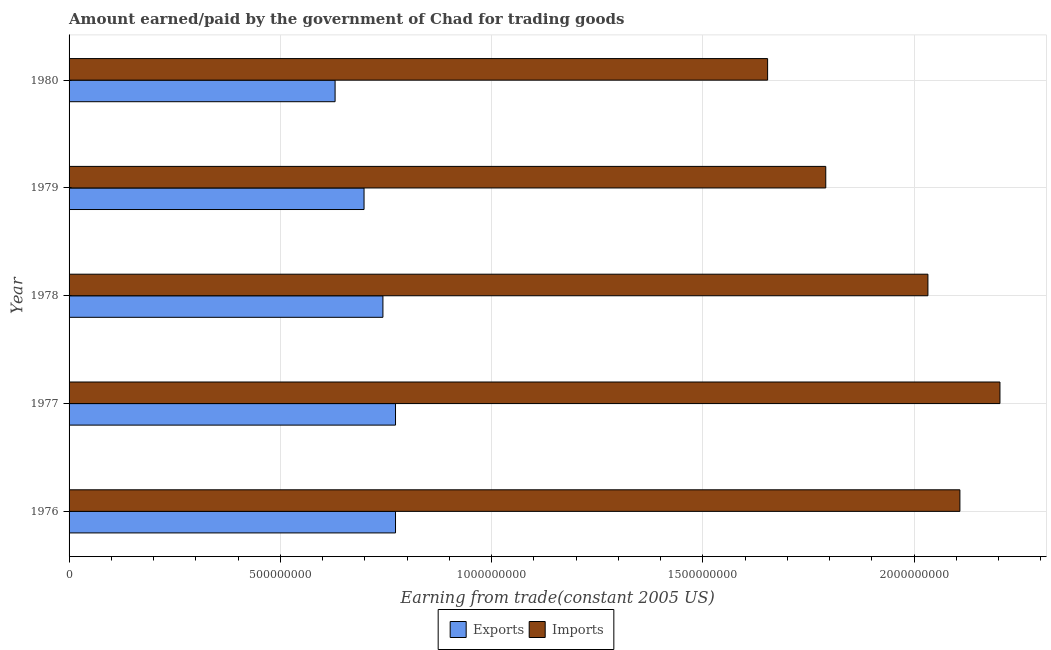How many groups of bars are there?
Make the answer very short. 5. What is the label of the 3rd group of bars from the top?
Make the answer very short. 1978. In how many cases, is the number of bars for a given year not equal to the number of legend labels?
Offer a very short reply. 0. What is the amount paid for imports in 1977?
Provide a succinct answer. 2.20e+09. Across all years, what is the maximum amount earned from exports?
Your answer should be very brief. 7.73e+08. Across all years, what is the minimum amount paid for imports?
Make the answer very short. 1.65e+09. In which year was the amount paid for imports minimum?
Keep it short and to the point. 1980. What is the total amount paid for imports in the graph?
Give a very brief answer. 9.79e+09. What is the difference between the amount earned from exports in 1976 and that in 1979?
Your answer should be very brief. 7.45e+07. What is the difference between the amount earned from exports in 1979 and the amount paid for imports in 1976?
Ensure brevity in your answer.  -1.41e+09. What is the average amount earned from exports per year?
Ensure brevity in your answer.  7.23e+08. In the year 1977, what is the difference between the amount earned from exports and amount paid for imports?
Keep it short and to the point. -1.43e+09. Is the amount earned from exports in 1978 less than that in 1979?
Offer a very short reply. No. What is the difference between the highest and the second highest amount paid for imports?
Your response must be concise. 9.48e+07. What is the difference between the highest and the lowest amount earned from exports?
Keep it short and to the point. 1.43e+08. In how many years, is the amount paid for imports greater than the average amount paid for imports taken over all years?
Offer a terse response. 3. What does the 2nd bar from the top in 1979 represents?
Your answer should be compact. Exports. What does the 1st bar from the bottom in 1976 represents?
Provide a short and direct response. Exports. How many bars are there?
Ensure brevity in your answer.  10. Are all the bars in the graph horizontal?
Give a very brief answer. Yes. How many years are there in the graph?
Ensure brevity in your answer.  5. What is the difference between two consecutive major ticks on the X-axis?
Make the answer very short. 5.00e+08. Does the graph contain grids?
Ensure brevity in your answer.  Yes. What is the title of the graph?
Offer a terse response. Amount earned/paid by the government of Chad for trading goods. Does "Under-five" appear as one of the legend labels in the graph?
Your answer should be very brief. No. What is the label or title of the X-axis?
Give a very brief answer. Earning from trade(constant 2005 US). What is the Earning from trade(constant 2005 US) of Exports in 1976?
Your answer should be very brief. 7.73e+08. What is the Earning from trade(constant 2005 US) of Imports in 1976?
Keep it short and to the point. 2.11e+09. What is the Earning from trade(constant 2005 US) in Exports in 1977?
Your answer should be very brief. 7.73e+08. What is the Earning from trade(constant 2005 US) in Imports in 1977?
Your answer should be compact. 2.20e+09. What is the Earning from trade(constant 2005 US) in Exports in 1978?
Your answer should be very brief. 7.43e+08. What is the Earning from trade(constant 2005 US) of Imports in 1978?
Your answer should be compact. 2.03e+09. What is the Earning from trade(constant 2005 US) of Exports in 1979?
Give a very brief answer. 6.98e+08. What is the Earning from trade(constant 2005 US) of Imports in 1979?
Your response must be concise. 1.79e+09. What is the Earning from trade(constant 2005 US) of Exports in 1980?
Your response must be concise. 6.30e+08. What is the Earning from trade(constant 2005 US) in Imports in 1980?
Offer a very short reply. 1.65e+09. Across all years, what is the maximum Earning from trade(constant 2005 US) in Exports?
Keep it short and to the point. 7.73e+08. Across all years, what is the maximum Earning from trade(constant 2005 US) of Imports?
Your answer should be very brief. 2.20e+09. Across all years, what is the minimum Earning from trade(constant 2005 US) in Exports?
Give a very brief answer. 6.30e+08. Across all years, what is the minimum Earning from trade(constant 2005 US) of Imports?
Keep it short and to the point. 1.65e+09. What is the total Earning from trade(constant 2005 US) of Exports in the graph?
Offer a terse response. 3.62e+09. What is the total Earning from trade(constant 2005 US) of Imports in the graph?
Provide a short and direct response. 9.79e+09. What is the difference between the Earning from trade(constant 2005 US) of Exports in 1976 and that in 1977?
Your answer should be very brief. -1.77e+04. What is the difference between the Earning from trade(constant 2005 US) of Imports in 1976 and that in 1977?
Your response must be concise. -9.48e+07. What is the difference between the Earning from trade(constant 2005 US) in Exports in 1976 and that in 1978?
Provide a succinct answer. 2.98e+07. What is the difference between the Earning from trade(constant 2005 US) in Imports in 1976 and that in 1978?
Keep it short and to the point. 7.57e+07. What is the difference between the Earning from trade(constant 2005 US) of Exports in 1976 and that in 1979?
Keep it short and to the point. 7.45e+07. What is the difference between the Earning from trade(constant 2005 US) of Imports in 1976 and that in 1979?
Ensure brevity in your answer.  3.17e+08. What is the difference between the Earning from trade(constant 2005 US) in Exports in 1976 and that in 1980?
Your answer should be very brief. 1.43e+08. What is the difference between the Earning from trade(constant 2005 US) in Imports in 1976 and that in 1980?
Ensure brevity in your answer.  4.55e+08. What is the difference between the Earning from trade(constant 2005 US) of Exports in 1977 and that in 1978?
Ensure brevity in your answer.  2.98e+07. What is the difference between the Earning from trade(constant 2005 US) in Imports in 1977 and that in 1978?
Offer a very short reply. 1.70e+08. What is the difference between the Earning from trade(constant 2005 US) in Exports in 1977 and that in 1979?
Keep it short and to the point. 7.45e+07. What is the difference between the Earning from trade(constant 2005 US) of Imports in 1977 and that in 1979?
Your answer should be very brief. 4.12e+08. What is the difference between the Earning from trade(constant 2005 US) in Exports in 1977 and that in 1980?
Give a very brief answer. 1.43e+08. What is the difference between the Earning from trade(constant 2005 US) of Imports in 1977 and that in 1980?
Provide a succinct answer. 5.50e+08. What is the difference between the Earning from trade(constant 2005 US) of Exports in 1978 and that in 1979?
Provide a succinct answer. 4.47e+07. What is the difference between the Earning from trade(constant 2005 US) of Imports in 1978 and that in 1979?
Give a very brief answer. 2.42e+08. What is the difference between the Earning from trade(constant 2005 US) of Exports in 1978 and that in 1980?
Your answer should be compact. 1.13e+08. What is the difference between the Earning from trade(constant 2005 US) in Imports in 1978 and that in 1980?
Keep it short and to the point. 3.79e+08. What is the difference between the Earning from trade(constant 2005 US) of Exports in 1979 and that in 1980?
Keep it short and to the point. 6.85e+07. What is the difference between the Earning from trade(constant 2005 US) in Imports in 1979 and that in 1980?
Your response must be concise. 1.38e+08. What is the difference between the Earning from trade(constant 2005 US) of Exports in 1976 and the Earning from trade(constant 2005 US) of Imports in 1977?
Your answer should be very brief. -1.43e+09. What is the difference between the Earning from trade(constant 2005 US) of Exports in 1976 and the Earning from trade(constant 2005 US) of Imports in 1978?
Offer a very short reply. -1.26e+09. What is the difference between the Earning from trade(constant 2005 US) of Exports in 1976 and the Earning from trade(constant 2005 US) of Imports in 1979?
Keep it short and to the point. -1.02e+09. What is the difference between the Earning from trade(constant 2005 US) of Exports in 1976 and the Earning from trade(constant 2005 US) of Imports in 1980?
Your answer should be very brief. -8.81e+08. What is the difference between the Earning from trade(constant 2005 US) in Exports in 1977 and the Earning from trade(constant 2005 US) in Imports in 1978?
Make the answer very short. -1.26e+09. What is the difference between the Earning from trade(constant 2005 US) in Exports in 1977 and the Earning from trade(constant 2005 US) in Imports in 1979?
Your answer should be very brief. -1.02e+09. What is the difference between the Earning from trade(constant 2005 US) of Exports in 1977 and the Earning from trade(constant 2005 US) of Imports in 1980?
Provide a succinct answer. -8.81e+08. What is the difference between the Earning from trade(constant 2005 US) in Exports in 1978 and the Earning from trade(constant 2005 US) in Imports in 1979?
Offer a very short reply. -1.05e+09. What is the difference between the Earning from trade(constant 2005 US) of Exports in 1978 and the Earning from trade(constant 2005 US) of Imports in 1980?
Provide a short and direct response. -9.10e+08. What is the difference between the Earning from trade(constant 2005 US) in Exports in 1979 and the Earning from trade(constant 2005 US) in Imports in 1980?
Provide a short and direct response. -9.55e+08. What is the average Earning from trade(constant 2005 US) in Exports per year?
Ensure brevity in your answer.  7.23e+08. What is the average Earning from trade(constant 2005 US) in Imports per year?
Your answer should be compact. 1.96e+09. In the year 1976, what is the difference between the Earning from trade(constant 2005 US) in Exports and Earning from trade(constant 2005 US) in Imports?
Keep it short and to the point. -1.34e+09. In the year 1977, what is the difference between the Earning from trade(constant 2005 US) of Exports and Earning from trade(constant 2005 US) of Imports?
Your response must be concise. -1.43e+09. In the year 1978, what is the difference between the Earning from trade(constant 2005 US) of Exports and Earning from trade(constant 2005 US) of Imports?
Make the answer very short. -1.29e+09. In the year 1979, what is the difference between the Earning from trade(constant 2005 US) in Exports and Earning from trade(constant 2005 US) in Imports?
Your answer should be very brief. -1.09e+09. In the year 1980, what is the difference between the Earning from trade(constant 2005 US) in Exports and Earning from trade(constant 2005 US) in Imports?
Your answer should be very brief. -1.02e+09. What is the ratio of the Earning from trade(constant 2005 US) of Exports in 1976 to that in 1977?
Provide a succinct answer. 1. What is the ratio of the Earning from trade(constant 2005 US) of Imports in 1976 to that in 1977?
Provide a succinct answer. 0.96. What is the ratio of the Earning from trade(constant 2005 US) in Exports in 1976 to that in 1978?
Make the answer very short. 1.04. What is the ratio of the Earning from trade(constant 2005 US) of Imports in 1976 to that in 1978?
Ensure brevity in your answer.  1.04. What is the ratio of the Earning from trade(constant 2005 US) in Exports in 1976 to that in 1979?
Give a very brief answer. 1.11. What is the ratio of the Earning from trade(constant 2005 US) of Imports in 1976 to that in 1979?
Provide a succinct answer. 1.18. What is the ratio of the Earning from trade(constant 2005 US) in Exports in 1976 to that in 1980?
Make the answer very short. 1.23. What is the ratio of the Earning from trade(constant 2005 US) in Imports in 1976 to that in 1980?
Keep it short and to the point. 1.28. What is the ratio of the Earning from trade(constant 2005 US) of Exports in 1977 to that in 1978?
Provide a succinct answer. 1.04. What is the ratio of the Earning from trade(constant 2005 US) of Imports in 1977 to that in 1978?
Provide a short and direct response. 1.08. What is the ratio of the Earning from trade(constant 2005 US) in Exports in 1977 to that in 1979?
Provide a short and direct response. 1.11. What is the ratio of the Earning from trade(constant 2005 US) of Imports in 1977 to that in 1979?
Ensure brevity in your answer.  1.23. What is the ratio of the Earning from trade(constant 2005 US) in Exports in 1977 to that in 1980?
Offer a terse response. 1.23. What is the ratio of the Earning from trade(constant 2005 US) in Imports in 1977 to that in 1980?
Offer a very short reply. 1.33. What is the ratio of the Earning from trade(constant 2005 US) in Exports in 1978 to that in 1979?
Your answer should be compact. 1.06. What is the ratio of the Earning from trade(constant 2005 US) of Imports in 1978 to that in 1979?
Give a very brief answer. 1.14. What is the ratio of the Earning from trade(constant 2005 US) of Exports in 1978 to that in 1980?
Offer a very short reply. 1.18. What is the ratio of the Earning from trade(constant 2005 US) in Imports in 1978 to that in 1980?
Keep it short and to the point. 1.23. What is the ratio of the Earning from trade(constant 2005 US) of Exports in 1979 to that in 1980?
Keep it short and to the point. 1.11. What is the difference between the highest and the second highest Earning from trade(constant 2005 US) in Exports?
Provide a short and direct response. 1.77e+04. What is the difference between the highest and the second highest Earning from trade(constant 2005 US) in Imports?
Offer a very short reply. 9.48e+07. What is the difference between the highest and the lowest Earning from trade(constant 2005 US) of Exports?
Your answer should be compact. 1.43e+08. What is the difference between the highest and the lowest Earning from trade(constant 2005 US) of Imports?
Your answer should be very brief. 5.50e+08. 